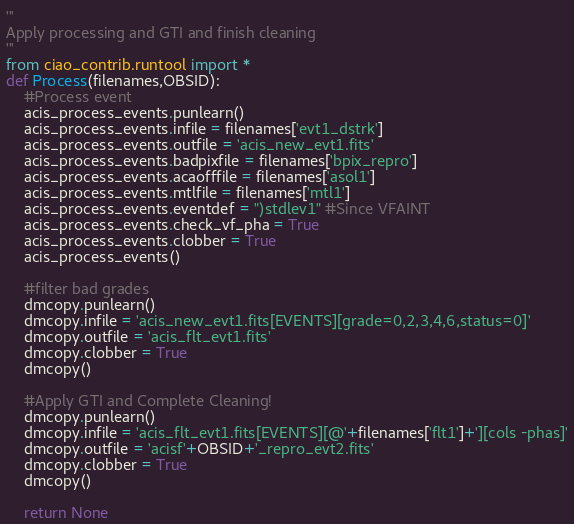Convert code to text. <code><loc_0><loc_0><loc_500><loc_500><_Python_>'''
Apply processing and GTI and finish cleaning
'''
from ciao_contrib.runtool import *
def Process(filenames,OBSID):
    #Process event
    acis_process_events.punlearn()
    acis_process_events.infile = filenames['evt1_dstrk']
    acis_process_events.outfile = 'acis_new_evt1.fits'
    acis_process_events.badpixfile = filenames['bpix_repro']
    acis_process_events.acaofffile = filenames['asol1']
    acis_process_events.mtlfile = filenames['mtl1']
    acis_process_events.eventdef = ")stdlev1" #Since VFAINT
    acis_process_events.check_vf_pha = True
    acis_process_events.clobber = True
    acis_process_events()

    #filter bad grades
    dmcopy.punlearn()
    dmcopy.infile = 'acis_new_evt1.fits[EVENTS][grade=0,2,3,4,6,status=0]'
    dmcopy.outfile = 'acis_flt_evt1.fits'
    dmcopy.clobber = True
    dmcopy()

    #Apply GTI and Complete Cleaning!
    dmcopy.punlearn()
    dmcopy.infile = 'acis_flt_evt1.fits[EVENTS][@'+filenames['flt1']+'][cols -phas]'
    dmcopy.outfile = 'acisf'+OBSID+'_repro_evt2.fits'
    dmcopy.clobber = True
    dmcopy()

    return None
</code> 